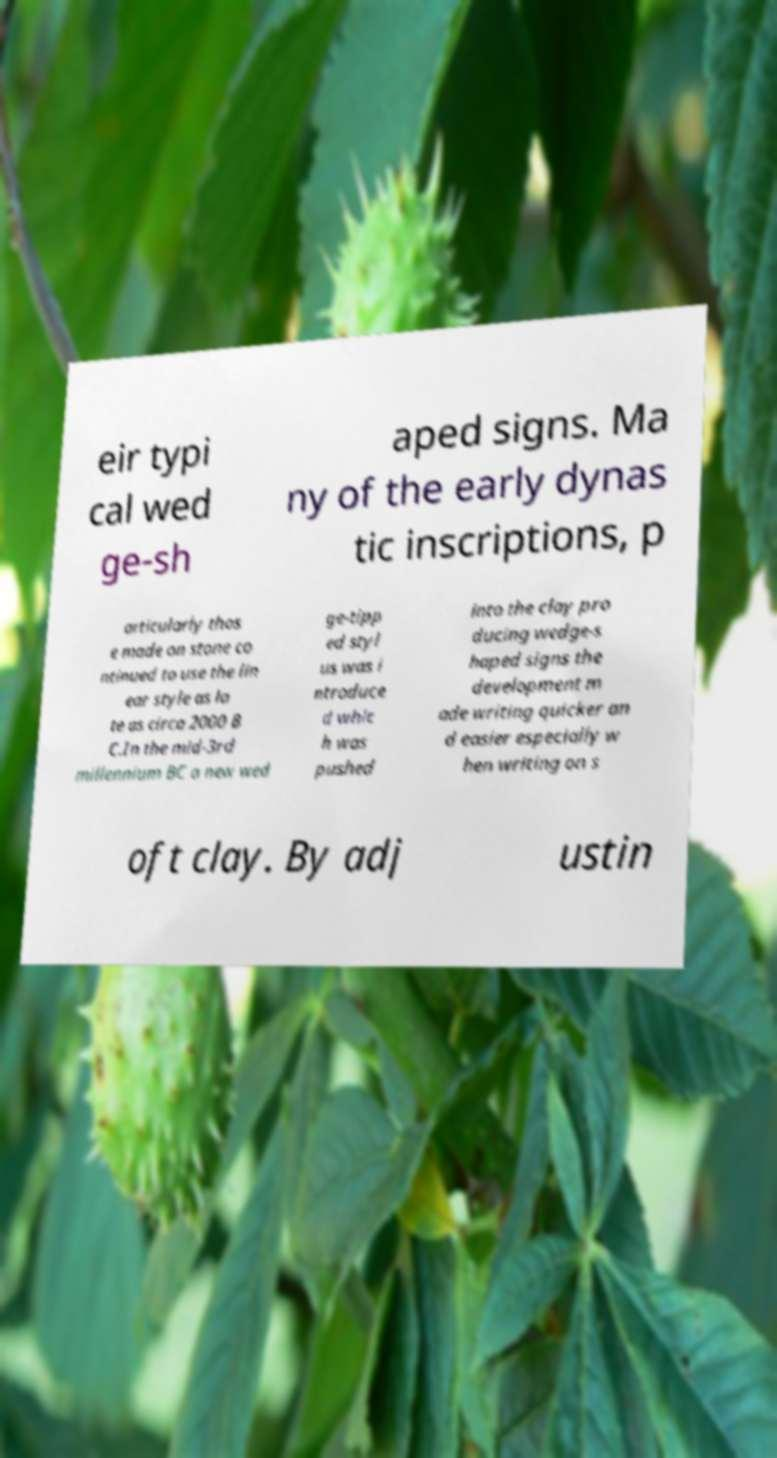Could you extract and type out the text from this image? eir typi cal wed ge-sh aped signs. Ma ny of the early dynas tic inscriptions, p articularly thos e made on stone co ntinued to use the lin ear style as la te as circa 2000 B C.In the mid-3rd millennium BC a new wed ge-tipp ed styl us was i ntroduce d whic h was pushed into the clay pro ducing wedge-s haped signs the development m ade writing quicker an d easier especially w hen writing on s oft clay. By adj ustin 